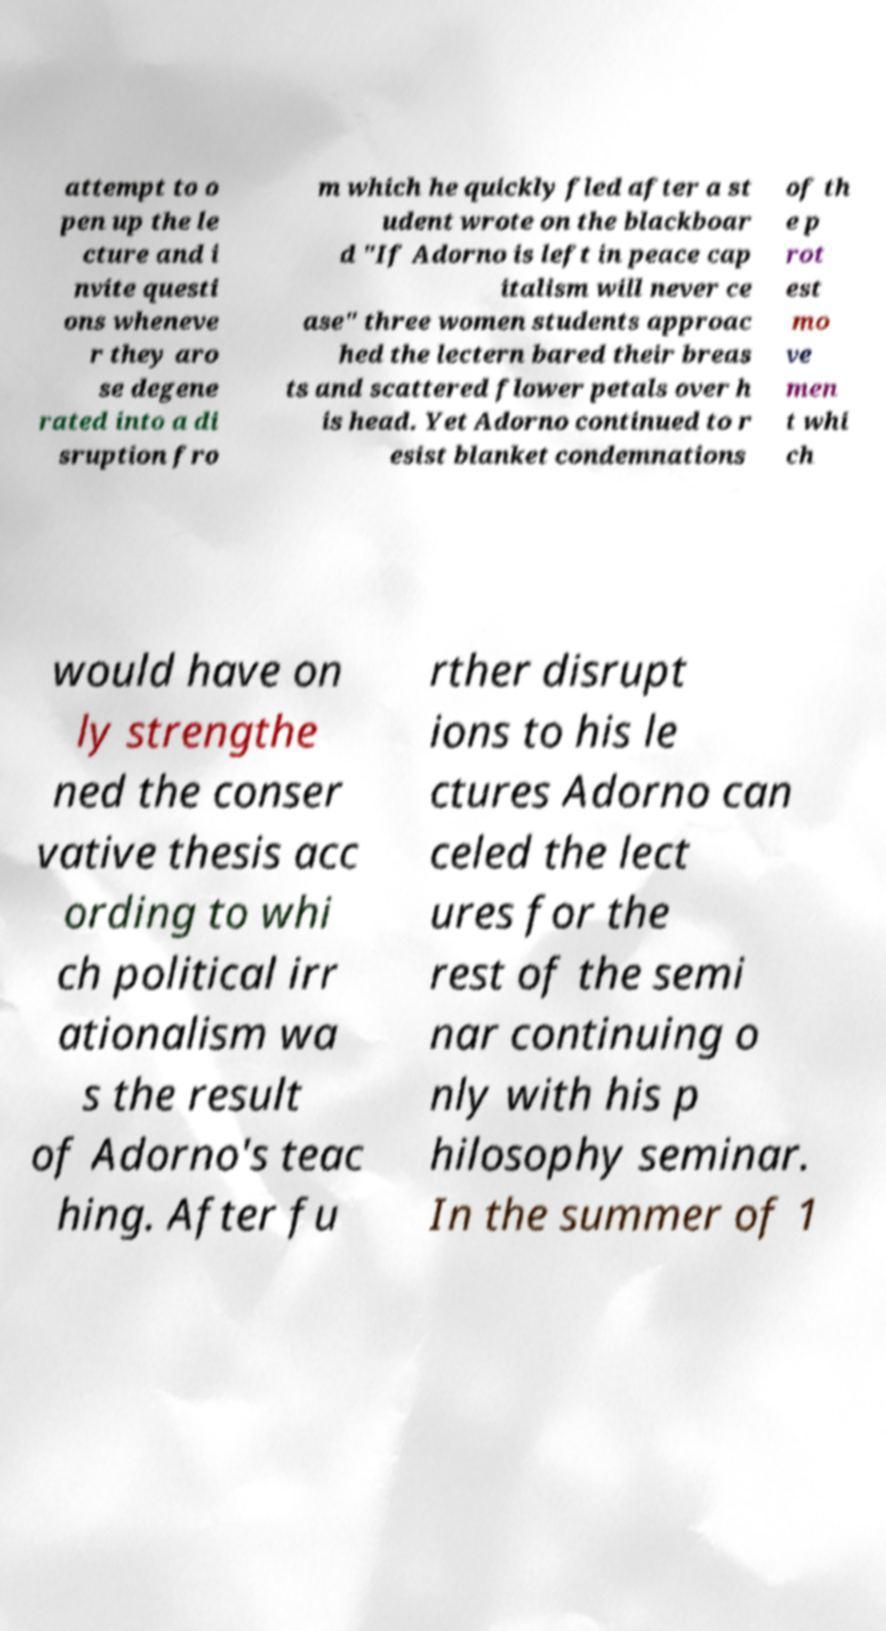Can you accurately transcribe the text from the provided image for me? attempt to o pen up the le cture and i nvite questi ons wheneve r they aro se degene rated into a di sruption fro m which he quickly fled after a st udent wrote on the blackboar d "If Adorno is left in peace cap italism will never ce ase" three women students approac hed the lectern bared their breas ts and scattered flower petals over h is head. Yet Adorno continued to r esist blanket condemnations of th e p rot est mo ve men t whi ch would have on ly strengthe ned the conser vative thesis acc ording to whi ch political irr ationalism wa s the result of Adorno's teac hing. After fu rther disrupt ions to his le ctures Adorno can celed the lect ures for the rest of the semi nar continuing o nly with his p hilosophy seminar. In the summer of 1 